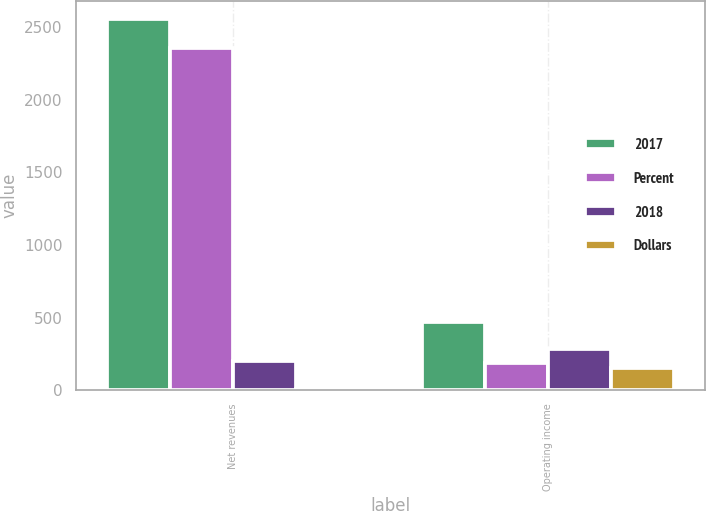Convert chart to OTSL. <chart><loc_0><loc_0><loc_500><loc_500><stacked_bar_chart><ecel><fcel>Net revenues<fcel>Operating income<nl><fcel>2017<fcel>2554<fcel>473<nl><fcel>Percent<fcel>2355<fcel>187<nl><fcel>2018<fcel>199<fcel>286<nl><fcel>Dollars<fcel>8<fcel>153<nl></chart> 